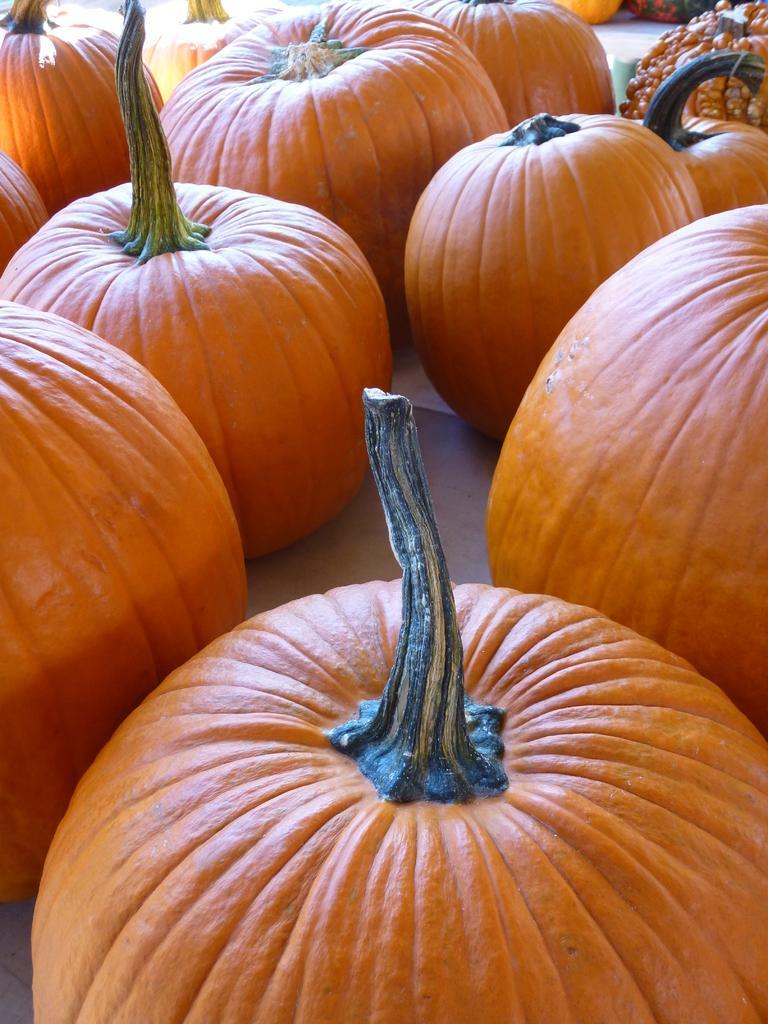Describe this image in one or two sentences. In this image we can see pumpkins. In the center of the image floor is there. 